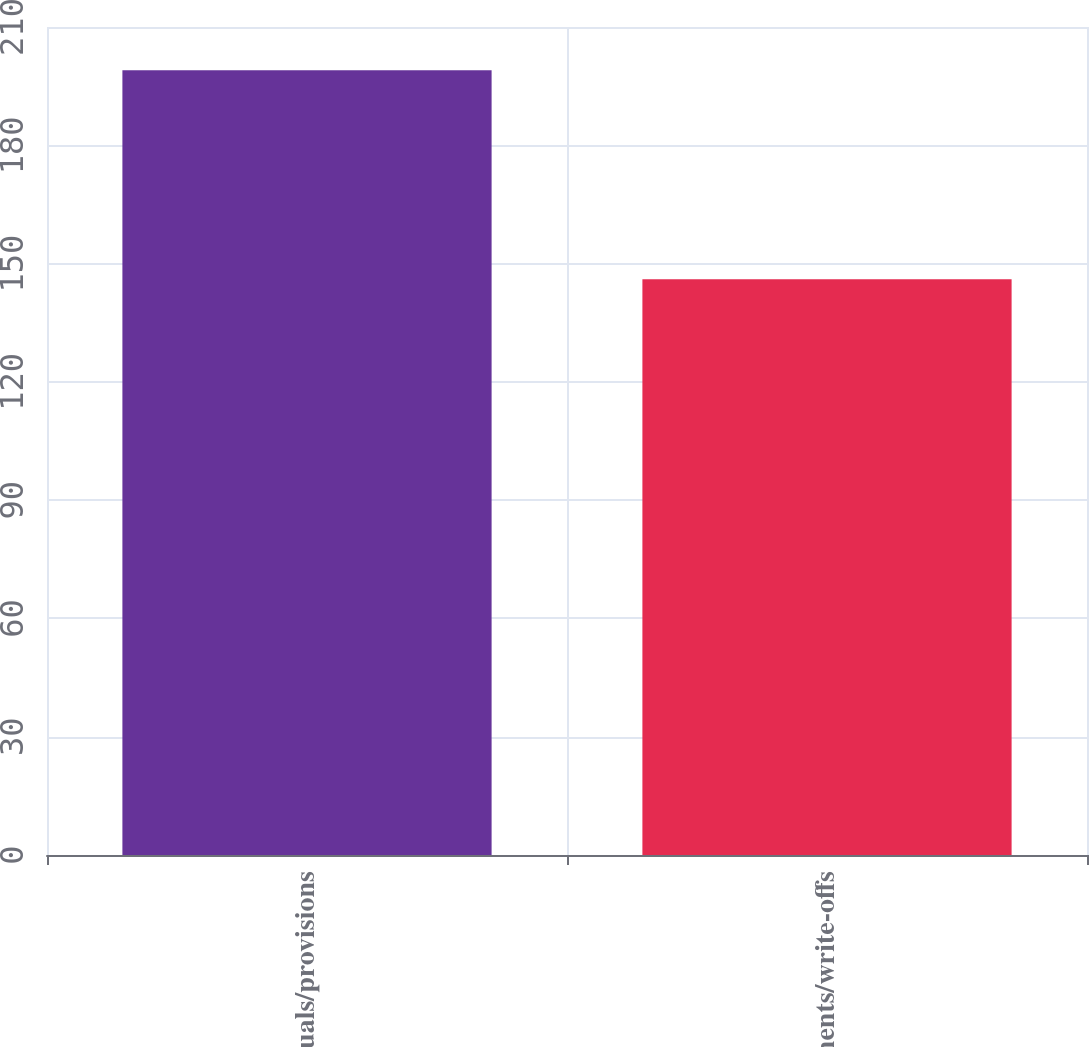<chart> <loc_0><loc_0><loc_500><loc_500><bar_chart><fcel>Accruals/provisions<fcel>Payments/write-offs<nl><fcel>199<fcel>146<nl></chart> 